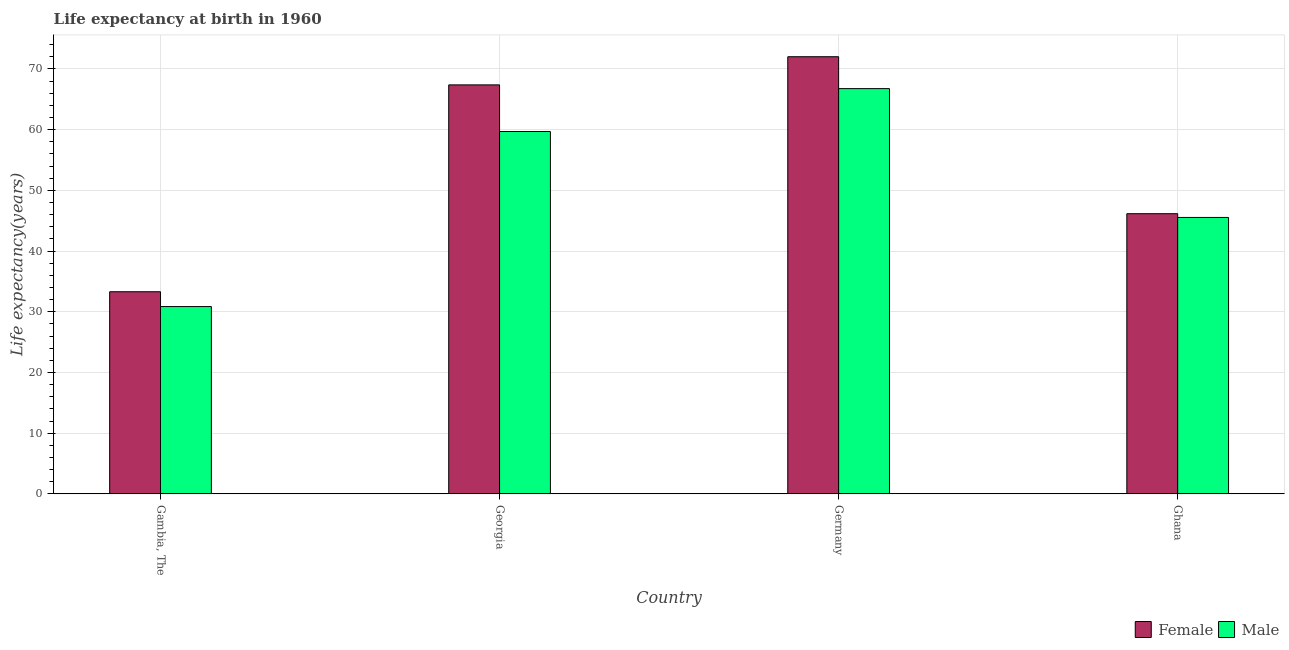How many different coloured bars are there?
Your answer should be compact. 2. How many bars are there on the 3rd tick from the right?
Keep it short and to the point. 2. In how many cases, is the number of bars for a given country not equal to the number of legend labels?
Ensure brevity in your answer.  0. What is the life expectancy(male) in Ghana?
Offer a terse response. 45.53. Across all countries, what is the maximum life expectancy(male)?
Offer a terse response. 66.75. Across all countries, what is the minimum life expectancy(male)?
Offer a very short reply. 30.85. In which country was the life expectancy(female) maximum?
Your answer should be compact. Germany. In which country was the life expectancy(male) minimum?
Provide a succinct answer. Gambia, The. What is the total life expectancy(male) in the graph?
Your answer should be very brief. 202.82. What is the difference between the life expectancy(female) in Georgia and that in Germany?
Your response must be concise. -4.64. What is the difference between the life expectancy(female) in Georgia and the life expectancy(male) in Germany?
Keep it short and to the point. 0.61. What is the average life expectancy(male) per country?
Give a very brief answer. 50.7. What is the difference between the life expectancy(male) and life expectancy(female) in Georgia?
Make the answer very short. -7.68. In how many countries, is the life expectancy(female) greater than 20 years?
Make the answer very short. 4. What is the ratio of the life expectancy(female) in Germany to that in Ghana?
Keep it short and to the point. 1.56. What is the difference between the highest and the second highest life expectancy(female)?
Provide a succinct answer. 4.64. What is the difference between the highest and the lowest life expectancy(male)?
Your response must be concise. 35.9. In how many countries, is the life expectancy(male) greater than the average life expectancy(male) taken over all countries?
Offer a terse response. 2. What does the 2nd bar from the right in Germany represents?
Provide a succinct answer. Female. Are all the bars in the graph horizontal?
Offer a terse response. No. What is the difference between two consecutive major ticks on the Y-axis?
Your answer should be compact. 10. Does the graph contain any zero values?
Your answer should be very brief. No. Where does the legend appear in the graph?
Your response must be concise. Bottom right. How many legend labels are there?
Provide a short and direct response. 2. How are the legend labels stacked?
Your answer should be very brief. Horizontal. What is the title of the graph?
Ensure brevity in your answer.  Life expectancy at birth in 1960. What is the label or title of the X-axis?
Provide a short and direct response. Country. What is the label or title of the Y-axis?
Your response must be concise. Life expectancy(years). What is the Life expectancy(years) of Female in Gambia, The?
Offer a terse response. 33.29. What is the Life expectancy(years) of Male in Gambia, The?
Offer a very short reply. 30.85. What is the Life expectancy(years) of Female in Georgia?
Give a very brief answer. 67.36. What is the Life expectancy(years) in Male in Georgia?
Ensure brevity in your answer.  59.69. What is the Life expectancy(years) of Female in Germany?
Provide a succinct answer. 72. What is the Life expectancy(years) of Male in Germany?
Provide a short and direct response. 66.75. What is the Life expectancy(years) in Female in Ghana?
Give a very brief answer. 46.15. What is the Life expectancy(years) of Male in Ghana?
Provide a short and direct response. 45.53. Across all countries, what is the maximum Life expectancy(years) in Female?
Give a very brief answer. 72. Across all countries, what is the maximum Life expectancy(years) in Male?
Offer a terse response. 66.75. Across all countries, what is the minimum Life expectancy(years) in Female?
Provide a succinct answer. 33.29. Across all countries, what is the minimum Life expectancy(years) in Male?
Keep it short and to the point. 30.85. What is the total Life expectancy(years) of Female in the graph?
Ensure brevity in your answer.  218.81. What is the total Life expectancy(years) in Male in the graph?
Provide a short and direct response. 202.82. What is the difference between the Life expectancy(years) of Female in Gambia, The and that in Georgia?
Your answer should be very brief. -34.07. What is the difference between the Life expectancy(years) of Male in Gambia, The and that in Georgia?
Your answer should be very brief. -28.84. What is the difference between the Life expectancy(years) in Female in Gambia, The and that in Germany?
Your answer should be compact. -38.71. What is the difference between the Life expectancy(years) in Male in Gambia, The and that in Germany?
Offer a terse response. -35.9. What is the difference between the Life expectancy(years) in Female in Gambia, The and that in Ghana?
Your answer should be very brief. -12.86. What is the difference between the Life expectancy(years) in Male in Gambia, The and that in Ghana?
Make the answer very short. -14.68. What is the difference between the Life expectancy(years) in Female in Georgia and that in Germany?
Provide a short and direct response. -4.64. What is the difference between the Life expectancy(years) of Male in Georgia and that in Germany?
Make the answer very short. -7.07. What is the difference between the Life expectancy(years) in Female in Georgia and that in Ghana?
Your answer should be very brief. 21.22. What is the difference between the Life expectancy(years) of Male in Georgia and that in Ghana?
Offer a very short reply. 14.16. What is the difference between the Life expectancy(years) of Female in Germany and that in Ghana?
Provide a succinct answer. 25.86. What is the difference between the Life expectancy(years) of Male in Germany and that in Ghana?
Make the answer very short. 21.22. What is the difference between the Life expectancy(years) in Female in Gambia, The and the Life expectancy(years) in Male in Georgia?
Offer a terse response. -26.39. What is the difference between the Life expectancy(years) in Female in Gambia, The and the Life expectancy(years) in Male in Germany?
Your answer should be very brief. -33.46. What is the difference between the Life expectancy(years) in Female in Gambia, The and the Life expectancy(years) in Male in Ghana?
Make the answer very short. -12.24. What is the difference between the Life expectancy(years) in Female in Georgia and the Life expectancy(years) in Male in Germany?
Provide a short and direct response. 0.61. What is the difference between the Life expectancy(years) of Female in Georgia and the Life expectancy(years) of Male in Ghana?
Make the answer very short. 21.84. What is the difference between the Life expectancy(years) of Female in Germany and the Life expectancy(years) of Male in Ghana?
Offer a very short reply. 26.47. What is the average Life expectancy(years) of Female per country?
Your answer should be very brief. 54.7. What is the average Life expectancy(years) in Male per country?
Give a very brief answer. 50.7. What is the difference between the Life expectancy(years) of Female and Life expectancy(years) of Male in Gambia, The?
Your answer should be compact. 2.44. What is the difference between the Life expectancy(years) of Female and Life expectancy(years) of Male in Georgia?
Keep it short and to the point. 7.68. What is the difference between the Life expectancy(years) in Female and Life expectancy(years) in Male in Germany?
Your answer should be very brief. 5.25. What is the difference between the Life expectancy(years) of Female and Life expectancy(years) of Male in Ghana?
Provide a succinct answer. 0.62. What is the ratio of the Life expectancy(years) in Female in Gambia, The to that in Georgia?
Offer a very short reply. 0.49. What is the ratio of the Life expectancy(years) in Male in Gambia, The to that in Georgia?
Offer a terse response. 0.52. What is the ratio of the Life expectancy(years) of Female in Gambia, The to that in Germany?
Provide a succinct answer. 0.46. What is the ratio of the Life expectancy(years) in Male in Gambia, The to that in Germany?
Ensure brevity in your answer.  0.46. What is the ratio of the Life expectancy(years) of Female in Gambia, The to that in Ghana?
Your response must be concise. 0.72. What is the ratio of the Life expectancy(years) in Male in Gambia, The to that in Ghana?
Your answer should be compact. 0.68. What is the ratio of the Life expectancy(years) of Female in Georgia to that in Germany?
Offer a very short reply. 0.94. What is the ratio of the Life expectancy(years) of Male in Georgia to that in Germany?
Ensure brevity in your answer.  0.89. What is the ratio of the Life expectancy(years) in Female in Georgia to that in Ghana?
Provide a short and direct response. 1.46. What is the ratio of the Life expectancy(years) in Male in Georgia to that in Ghana?
Provide a short and direct response. 1.31. What is the ratio of the Life expectancy(years) in Female in Germany to that in Ghana?
Provide a short and direct response. 1.56. What is the ratio of the Life expectancy(years) in Male in Germany to that in Ghana?
Offer a terse response. 1.47. What is the difference between the highest and the second highest Life expectancy(years) in Female?
Your answer should be very brief. 4.64. What is the difference between the highest and the second highest Life expectancy(years) in Male?
Your response must be concise. 7.07. What is the difference between the highest and the lowest Life expectancy(years) of Female?
Give a very brief answer. 38.71. What is the difference between the highest and the lowest Life expectancy(years) of Male?
Provide a succinct answer. 35.9. 